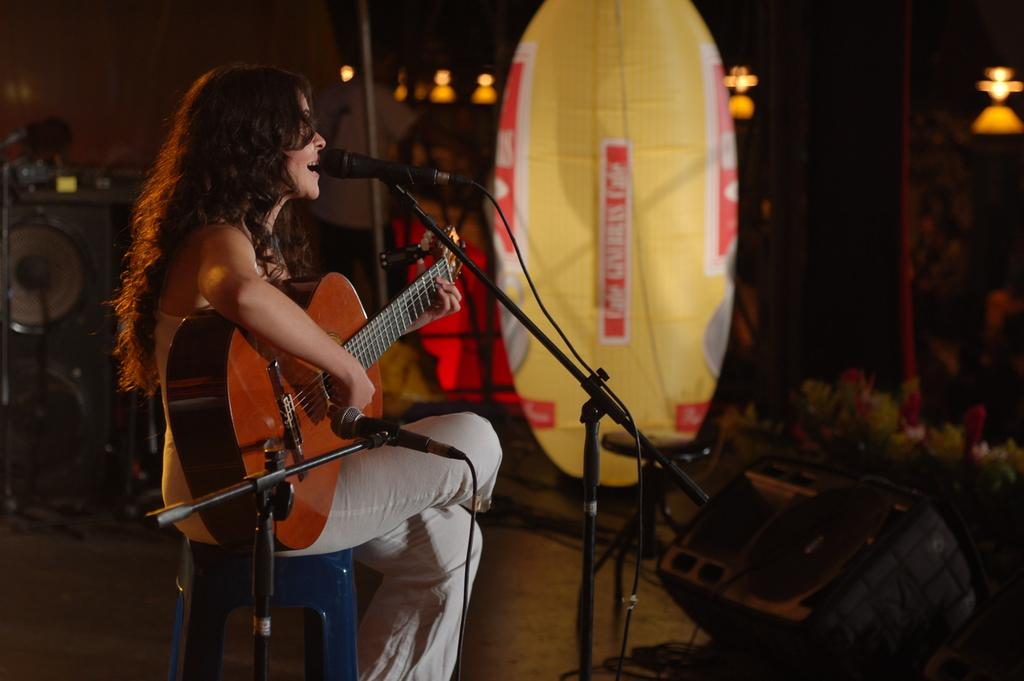Who is the main subject in the image? There is a woman in the image. What is the woman doing in the image? The woman is sitting and singing. What object is the woman holding in the image? The woman is holding a guitar. What device is in front of the woman? There is a microphone in front of the woman. What type of chance game is the woman playing in the image? There is no chance game present in the image; the woman is singing and holding a guitar. What type of oven can be seen in the image? There is no oven present in the image. 